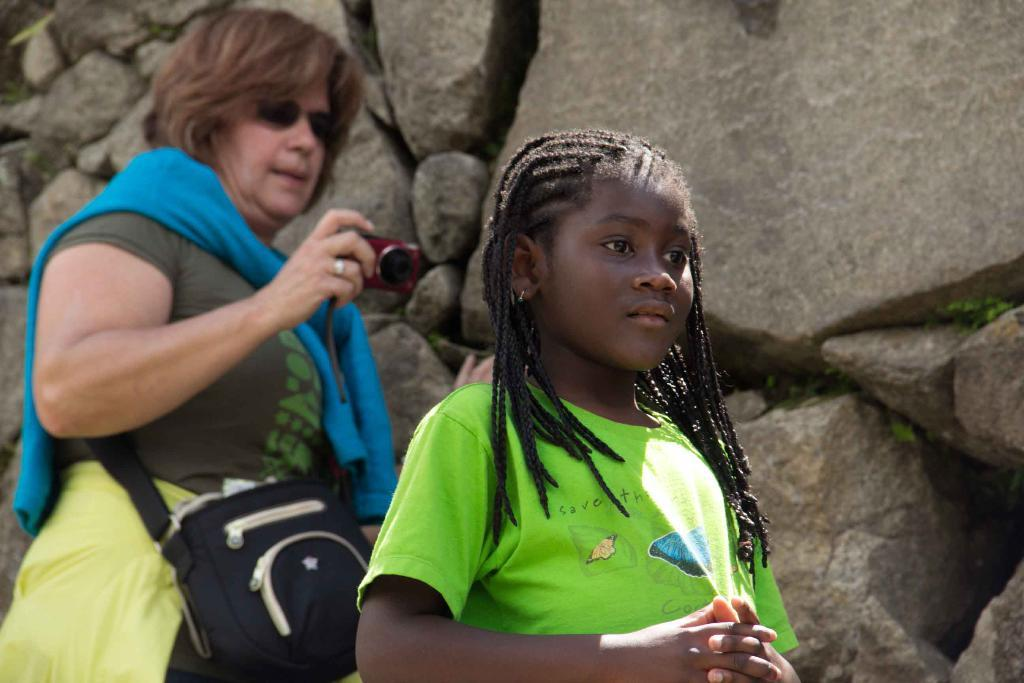Who is the main subject in the foreground of the picture? There is a girl in the foreground of the picture. What can be seen in the background of the picture? There is a woman in the background of the picture, and there are rocks in the background as well. What is the woman holding in the picture? The woman is holding a camera. What is the woman wearing in the picture? The woman is wearing a bag. What type of quartz can be seen on the girl's skin in the image? There is no quartz visible on the girl's skin in the image. Is there a boat in the background of the picture? No, there is no boat present in the image. 